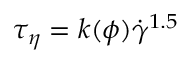<formula> <loc_0><loc_0><loc_500><loc_500>{ { \tau } _ { \eta } } = k ( \phi ) { { \dot { \gamma } } ^ { 1 . 5 } }</formula> 